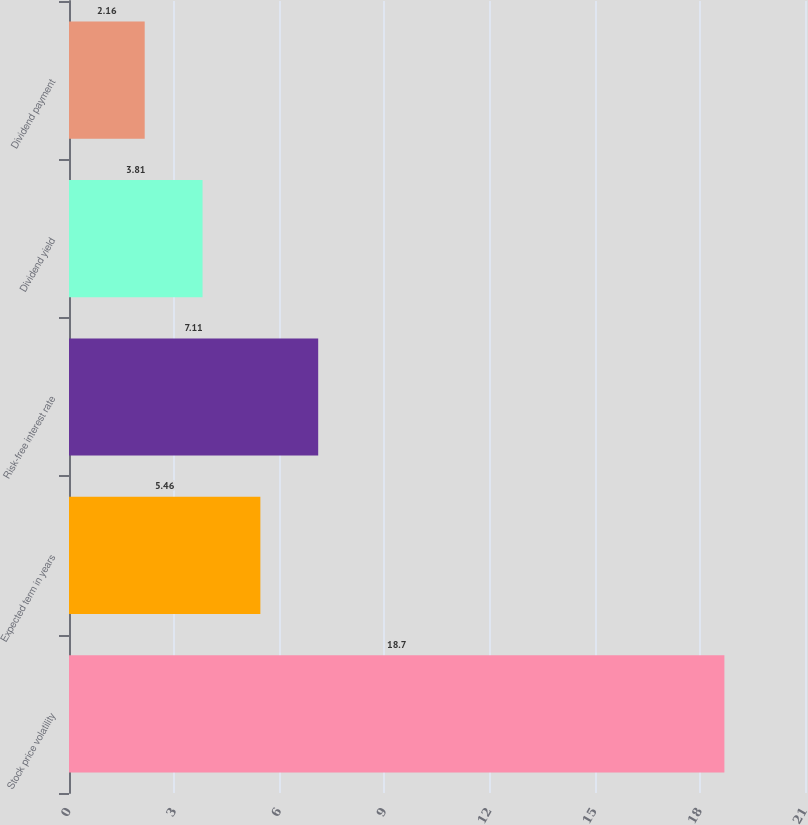<chart> <loc_0><loc_0><loc_500><loc_500><bar_chart><fcel>Stock price volatility<fcel>Expected term in years<fcel>Risk-free interest rate<fcel>Dividend yield<fcel>Dividend payment<nl><fcel>18.7<fcel>5.46<fcel>7.11<fcel>3.81<fcel>2.16<nl></chart> 